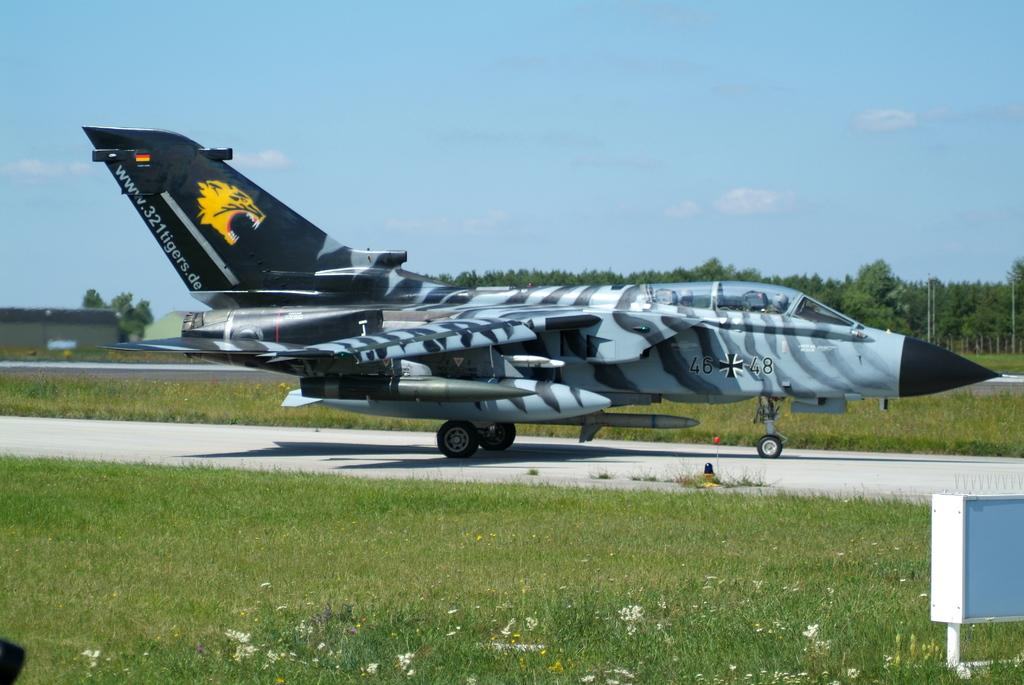Provide a one-sentence caption for the provided image. A German fighter plane that is part of the Tigers squad. 